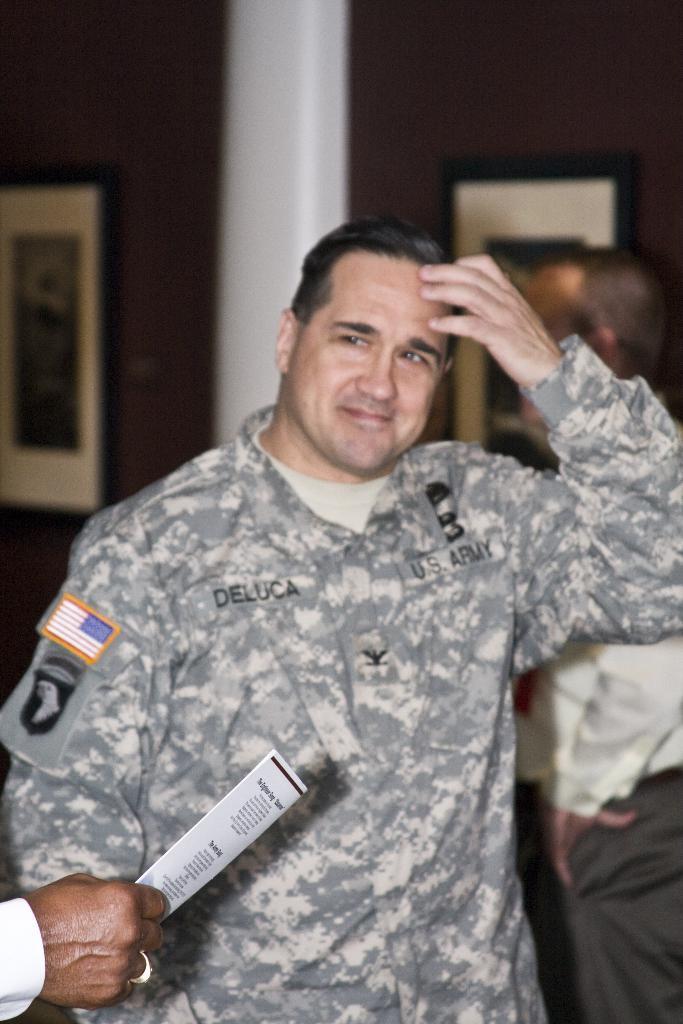Could you give a brief overview of what you see in this image? In this image we can see a man standing. On the backside we can see a person standing and some frames on a wall. On the bottom left we can see the hand of a person holding some papers. 